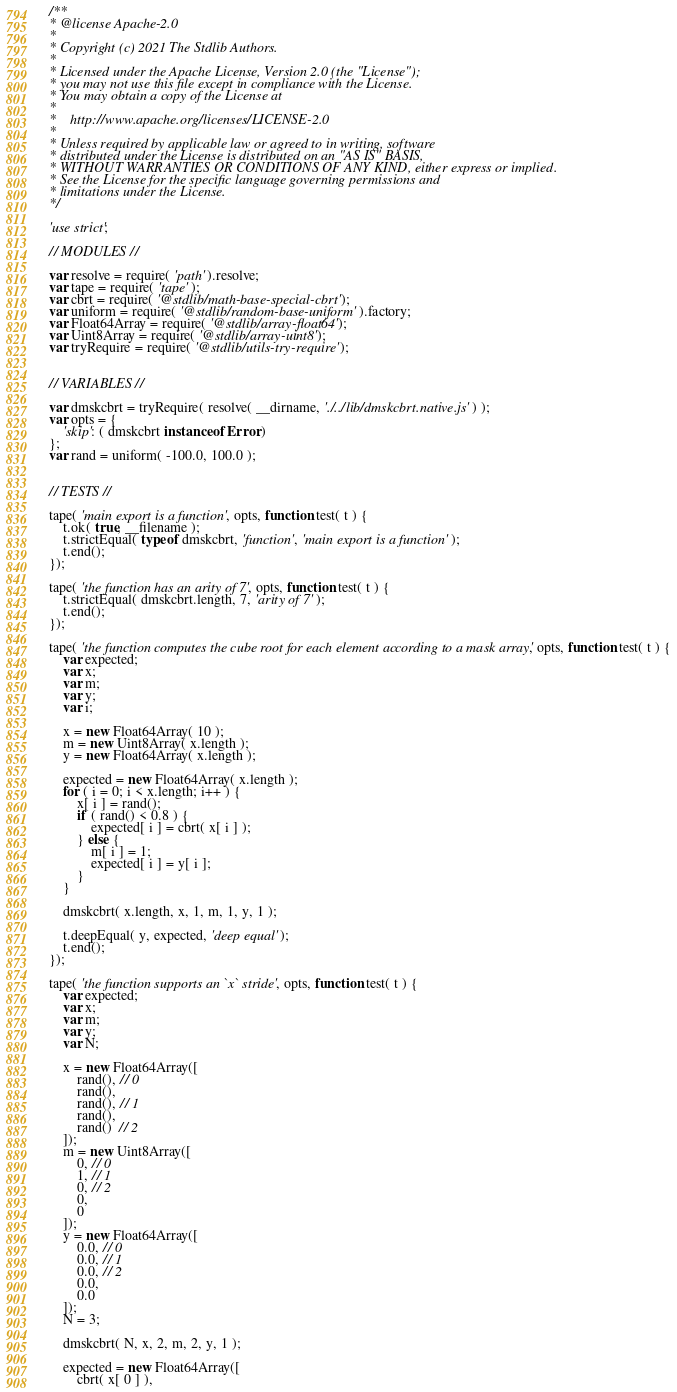Convert code to text. <code><loc_0><loc_0><loc_500><loc_500><_JavaScript_>/**
* @license Apache-2.0
*
* Copyright (c) 2021 The Stdlib Authors.
*
* Licensed under the Apache License, Version 2.0 (the "License");
* you may not use this file except in compliance with the License.
* You may obtain a copy of the License at
*
*    http://www.apache.org/licenses/LICENSE-2.0
*
* Unless required by applicable law or agreed to in writing, software
* distributed under the License is distributed on an "AS IS" BASIS,
* WITHOUT WARRANTIES OR CONDITIONS OF ANY KIND, either express or implied.
* See the License for the specific language governing permissions and
* limitations under the License.
*/

'use strict';

// MODULES //

var resolve = require( 'path' ).resolve;
var tape = require( 'tape' );
var cbrt = require( '@stdlib/math-base-special-cbrt' );
var uniform = require( '@stdlib/random-base-uniform' ).factory;
var Float64Array = require( '@stdlib/array-float64' );
var Uint8Array = require( '@stdlib/array-uint8' );
var tryRequire = require( '@stdlib/utils-try-require' );


// VARIABLES //

var dmskcbrt = tryRequire( resolve( __dirname, './../lib/dmskcbrt.native.js' ) );
var opts = {
	'skip': ( dmskcbrt instanceof Error )
};
var rand = uniform( -100.0, 100.0 );


// TESTS //

tape( 'main export is a function', opts, function test( t ) {
	t.ok( true, __filename );
	t.strictEqual( typeof dmskcbrt, 'function', 'main export is a function' );
	t.end();
});

tape( 'the function has an arity of 7', opts, function test( t ) {
	t.strictEqual( dmskcbrt.length, 7, 'arity of 7' );
	t.end();
});

tape( 'the function computes the cube root for each element according to a mask array', opts, function test( t ) {
	var expected;
	var x;
	var m;
	var y;
	var i;

	x = new Float64Array( 10 );
	m = new Uint8Array( x.length );
	y = new Float64Array( x.length );

	expected = new Float64Array( x.length );
	for ( i = 0; i < x.length; i++ ) {
		x[ i ] = rand();
		if ( rand() < 0.8 ) {
			expected[ i ] = cbrt( x[ i ] );
		} else {
			m[ i ] = 1;
			expected[ i ] = y[ i ];
		}
	}

	dmskcbrt( x.length, x, 1, m, 1, y, 1 );

	t.deepEqual( y, expected, 'deep equal' );
	t.end();
});

tape( 'the function supports an `x` stride', opts, function test( t ) {
	var expected;
	var x;
	var m;
	var y;
	var N;

	x = new Float64Array([
		rand(), // 0
		rand(),
		rand(), // 1
		rand(),
		rand()  // 2
	]);
	m = new Uint8Array([
		0, // 0
		1, // 1
		0, // 2
		0,
		0
	]);
	y = new Float64Array([
		0.0, // 0
		0.0, // 1
		0.0, // 2
		0.0,
		0.0
	]);
	N = 3;

	dmskcbrt( N, x, 2, m, 2, y, 1 );

	expected = new Float64Array([
		cbrt( x[ 0 ] ),</code> 